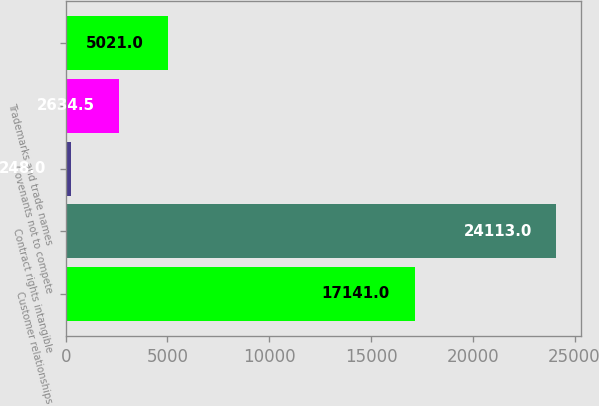Convert chart. <chart><loc_0><loc_0><loc_500><loc_500><bar_chart><fcel>Customer relationships<fcel>Contract rights intangible<fcel>Covenants not to compete<fcel>Trademarks and trade names<fcel>Unnamed: 4<nl><fcel>17141<fcel>24113<fcel>248<fcel>2634.5<fcel>5021<nl></chart> 